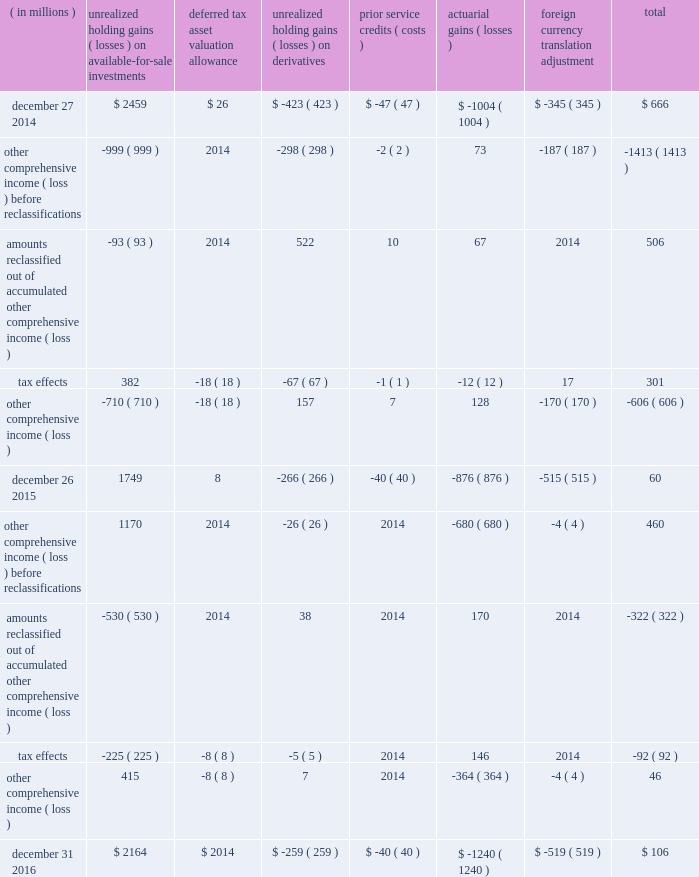Intel corporation notes to consolidated financial statements ( continued ) note 16 : other comprehensive income ( loss ) the changes in accumulated other comprehensive income ( loss ) by component and related tax effects for each period were as follows : ( in millions ) unrealized holding ( losses ) on available- for-sale investments deferred tax asset valuation allowance unrealized holding ( losses ) on derivatives service credits ( costs ) actuarial ( losses ) foreign currency translation adjustment total .

What is the net change in accumulated other comprehensive income during 2016? 
Computations: (106 - 60)
Answer: 46.0. 